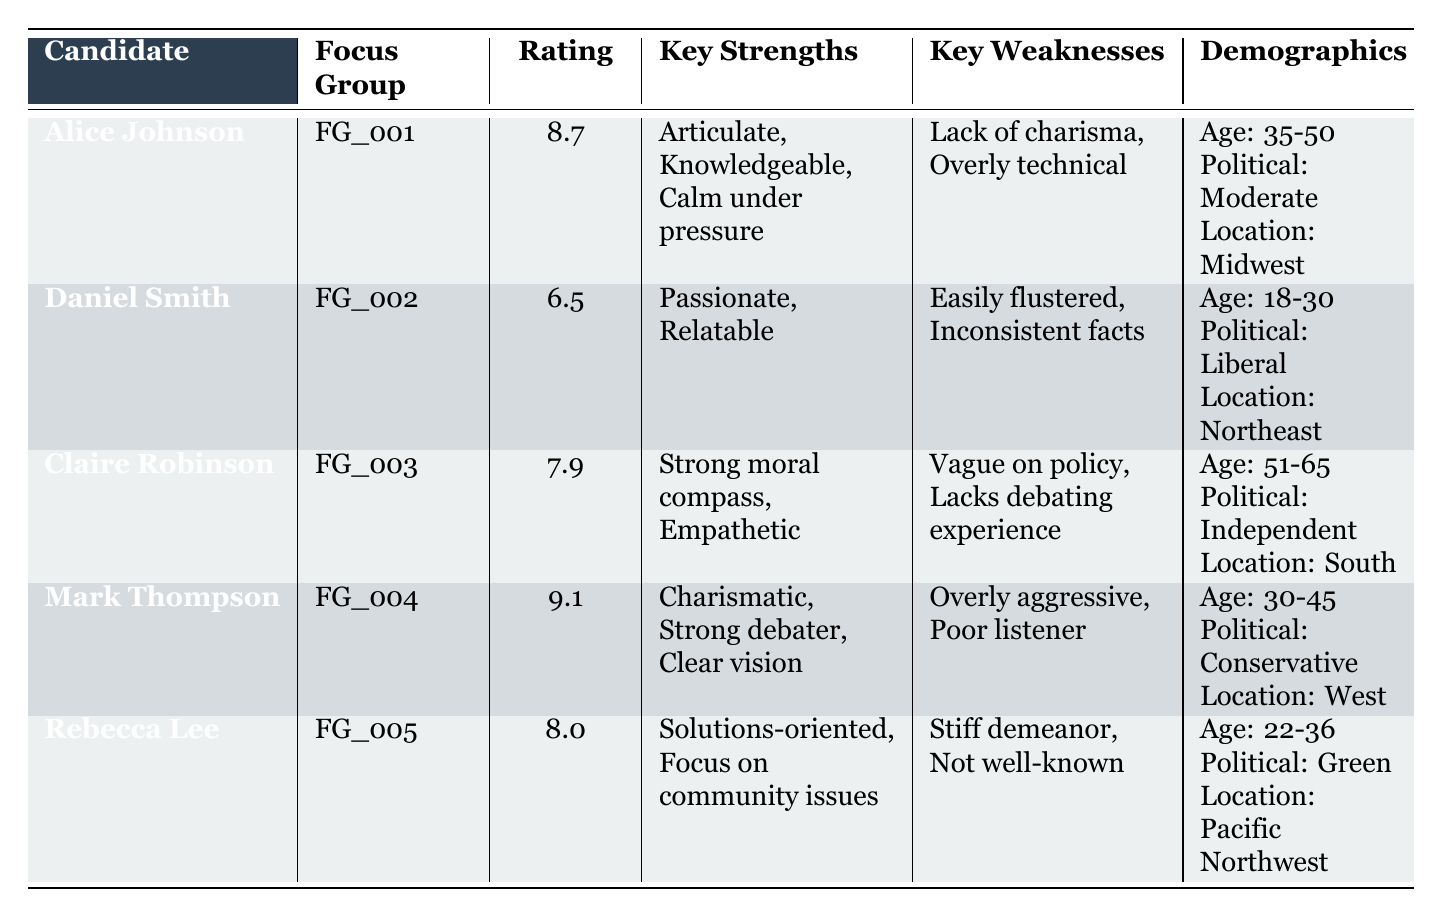What is the performance rating of Mark Thompson? The table directly shows that Mark Thompson's performance rating is 9.1.
Answer: 9.1 Which candidate has the lowest performance rating? By scanning through the performance ratings, Daniel Smith has the lowest score at 6.5.
Answer: Daniel Smith What are the key strengths of Claire Robinson? The table lists Claire Robinson's key strengths as Strong moral compass and Empathetic.
Answer: Strong moral compass, Empathetic Which candidate has a focus group demographic of ages 22-36? Looking at the demographics, Rebecca Lee fits this age range as indicated in her information.
Answer: Rebecca Lee What is the average performance rating of the candidates? First, we sum the ratings: 8.7 + 6.5 + 7.9 + 9.1 + 8.0 = 40.2. There are 5 candidates, so the average is 40.2 / 5 = 8.04.
Answer: 8.04 Is Alice Johnson considered charismatic according to the table? The key weaknesses for Alice Johnson listed in the table do not include charisma, but her key strengths do not mention charisma either, implying she is not considered charismatic.
Answer: No Which candidate has the strongest debate rating among those with a liberal political affiliation? The only candidate with a liberal affiliation is Daniel Smith, who has a performance rating of 6.5. Given he is the only one, he has the highest rating by default.
Answer: Daniel Smith What is the difference in performance ratings between Mark Thompson and Rebecca Lee? The ratings are 9.1 for Mark Thompson and 8.0 for Rebecca Lee. The difference is 9.1 - 8.0 = 1.1.
Answer: 1.1 Does any candidate have a focus group demographic of age 51-65? Yes, the table shows that Claire Robinson belongs to the age range of 51-65.
Answer: Yes 